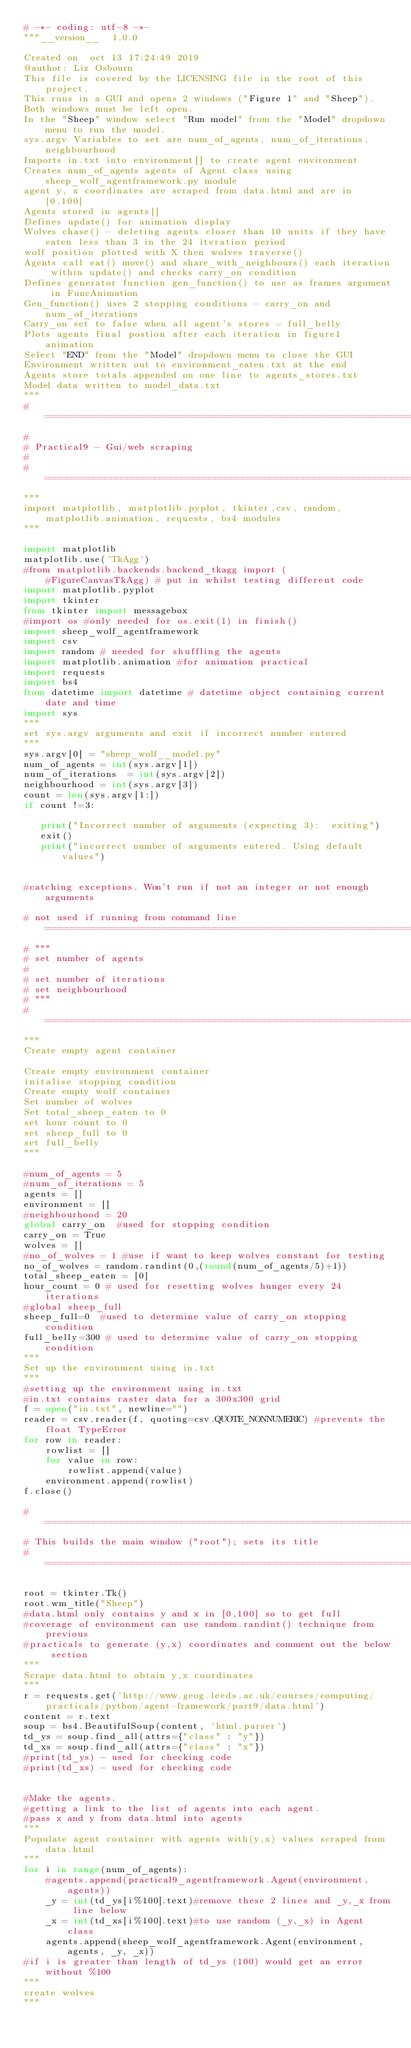Convert code to text. <code><loc_0><loc_0><loc_500><loc_500><_Python_># -*- coding: utf-8 -*-
"""__version__  1.0.0

Created on  oct 13 17:24:49 2019
@author: Liz Osbourn
This file is covered by the LICENSING file in the root of this project.
This runs in a GUI and opens 2 windows ("Figure 1" and "Sheep").
Both windows must be left open. 
In the "Sheep" window select "Run model" from the "Model" dropdown menu to run the model. 
sys.argv Variables to set are num_of_agents, num_of_iterations, neighbourhood
Imports in.txt into environment[] to create agent environment
Creates num_of_agents agents of Agent class using sheep_wolf_agentframework.py module
agent y, x coordinates are scraped from data.html and are in [0,100]
Agents stored in agents[]
Defines update() for animation display
Wolves chase() - deleting agents closer than 10 units if they have eaten less than 3 in the 24 iteration period
wolf position plotted with X then wolves traverse()
Agents call eat() move() and share_with_neighbours() each iteration within update() and checks carry_on condition
Defines generator function gen_function() to use as frames argument in FuncAnimation
Gen_function() uses 2 stopping conditions - carry_on and num_of_iterations
Carry_on set to false when all agent's stores = full_belly
Plots agents final postion after each iteration in figure1 animation
Select "END" from the "Model" dropdown menu to close the GUI
Environment written out to environment_eaten.txt at the end
Agents store totals appended on one line to agents_stores.txt
Model data written to model_data.txt
"""
# =============================================================================
# 
# Practical9 - Gui/web scraping
# 
# =============================================================================
"""
import matplotlib, matplotlib.pyplot, tkinter,csv, random, matplotlib.animation, requests, bs4 modules
"""

import matplotlib
matplotlib.use('TkAgg')
#from matplotlib.backends.backend_tkagg import (
    #FigureCanvasTkAgg) # put in whilst testing different code
import matplotlib.pyplot
import tkinter
from tkinter import messagebox
#import os #only needed for os.exit(1) in finish()
import sheep_wolf_agentframework
import csv
import random # needed for shuffling the agents
import matplotlib.animation #for animation practical
import requests
import bs4
from datetime import datetime # datetime object containing current date and time
import sys 
"""
set sys.argv arguments and exit if incorrect number entered
"""
sys.argv[0] = "sheep_wolf__model.py"
num_of_agents = int(sys.argv[1])
num_of_iterations  = int(sys.argv[2])
neighbourhood = int(sys.argv[3])
count = len(sys.argv[1:])
if count !=3:

   print("Incorrect number of arguments (expecting 3):  exiting")
   exit()
   print("incorrect number of arguments entered. Using default values")


#catching exceptions. Won't run if not an integer or not enough arguments

# not used if running from command line=============================================================================
# """
# set number of agents
# 
# set number of iterations
# set neighbourhood
# """
# =============================================================================
"""
Create empty agent container

Create empty environment container
initalise stopping condition
Create empty wolf container
Set number of wolves
Set total_sheep_eaten to 0
set hour count to 0
set sheep_full to 0
set full_belly
"""

#num_of_agents = 5
#num_of_iterations = 5
agents = []
environment = []
#neighbourhood = 20
global carry_on	 #used for stopping condition
carry_on = True
wolves = []
#no_of_wolves = 1 #use if want to keep wolves constant for testing
no_of_wolves = random.randint(0,(round(num_of_agents/5)+1))
total_sheep_eaten = [0]
hour_count = 0 # used for resetting wolves hunger every 24 iterations
#global sheep_full
sheep_full=0  #used to determine value of carry_on stopping condition
full_belly=300 # used to determine value of carry_on stopping condition
"""
Set up the environment using in.txt
"""
#setting up the environment using in.txt
#in.txt contains raster data for a 300x300 grid
f = open("in.txt", newline="")
reader = csv.reader(f, quoting=csv.QUOTE_NONNUMERIC) #prevents the float TypeError
for row in reader:
    rowlist = []
    for value in row:
        rowlist.append(value)
    environment.append(rowlist)
f.close()

# =============================================================================
# This builds the main window ("root"); sets its title
# =============================================================================

root = tkinter.Tk() 
root.wm_title("Sheep")
#data.html only contains y and x in [0,100] so to get full
#coverage of environment can use random.randint() technique from previous
#practicals to generate (y,x) coordinates and comment out the below section
"""
Scrape data.html to obtain y,x coordinates
"""
r = requests.get('http://www.geog.leeds.ac.uk/courses/computing/practicals/python/agent-framework/part9/data.html')
content = r.text
soup = bs4.BeautifulSoup(content, 'html.parser')
td_ys = soup.find_all(attrs={"class" : "y"})
td_xs = soup.find_all(attrs={"class" : "x"})
#print(td_ys) - used for checking code
#print(td_xs) - used for checking code


#Make the agents.
#getting a link to the list of agents into each agent. 
#pass x and y from data.html into agents 
"""
Populate agent container with agents with(y,x) values scraped from data.html
""" 
for i in range(num_of_agents):
    #agents.append(practical9_agentframework.Agent(environment, agents))
    _y = int(td_ys[i%100].text)#remove these 2 lines and _y,_x from line below 
    _x = int(td_xs[i%100].text)#to use random (_y,_x) in Agent class
    agents.append(sheep_wolf_agentframework.Agent(environment, agents, _y, _x))
#if i is greater than length of td_ys (100) would get an error without %100
"""
create wolves
"""</code> 